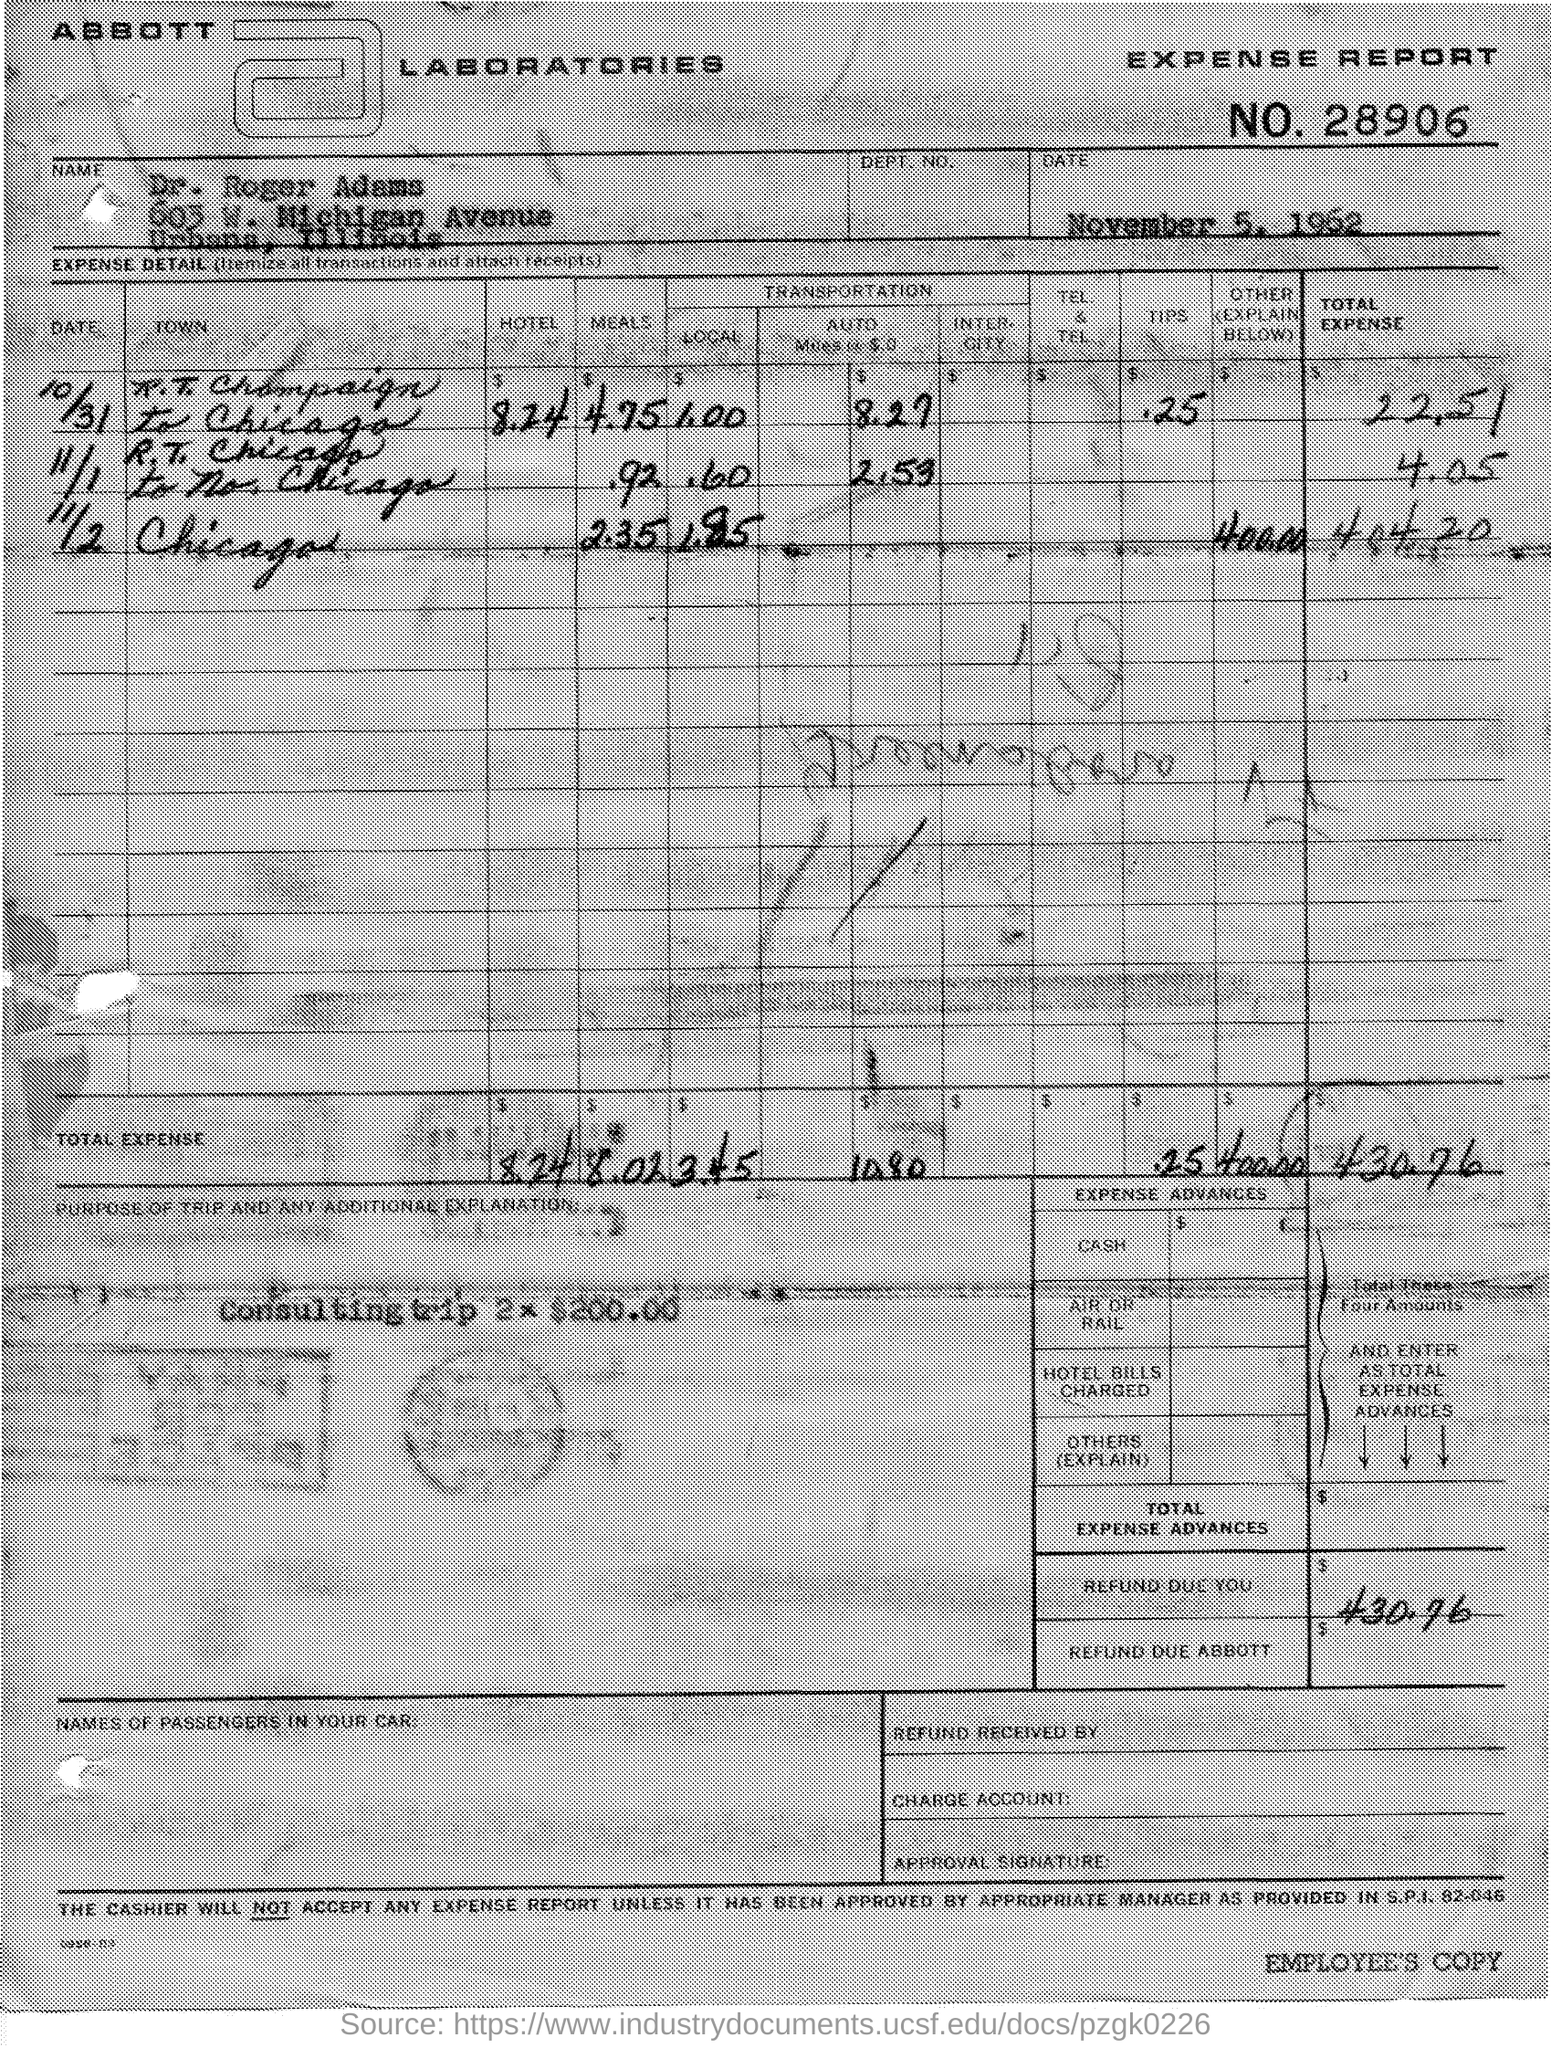Whats the EXPENSE REPORT NO.?
Ensure brevity in your answer.  28906. When was it dated?
Provide a short and direct response. November 5, 1962. Whats Lab name on the form?
Keep it short and to the point. ABBOTT LABORATORIES. Whose Expense Details were there?
Make the answer very short. Dr. Roger Adams. What are the other expenses in Chicago trip(11/2)?
Your answer should be compact. 400.00. When was r.t.chicago to no. chicago trip?
Offer a terse response. 11/1. How many dollars were REFUNDED?
Ensure brevity in your answer.  430.76. 